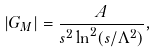Convert formula to latex. <formula><loc_0><loc_0><loc_500><loc_500>| G _ { M } | = \frac { A } { s ^ { 2 } \ln ^ { 2 } ( s / \Lambda ^ { 2 } ) } ,</formula> 